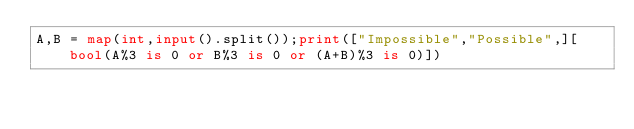Convert code to text. <code><loc_0><loc_0><loc_500><loc_500><_Python_>A,B = map(int,input().split());print(["Impossible","Possible",][bool(A%3 is 0 or B%3 is 0 or (A+B)%3 is 0)])
</code> 